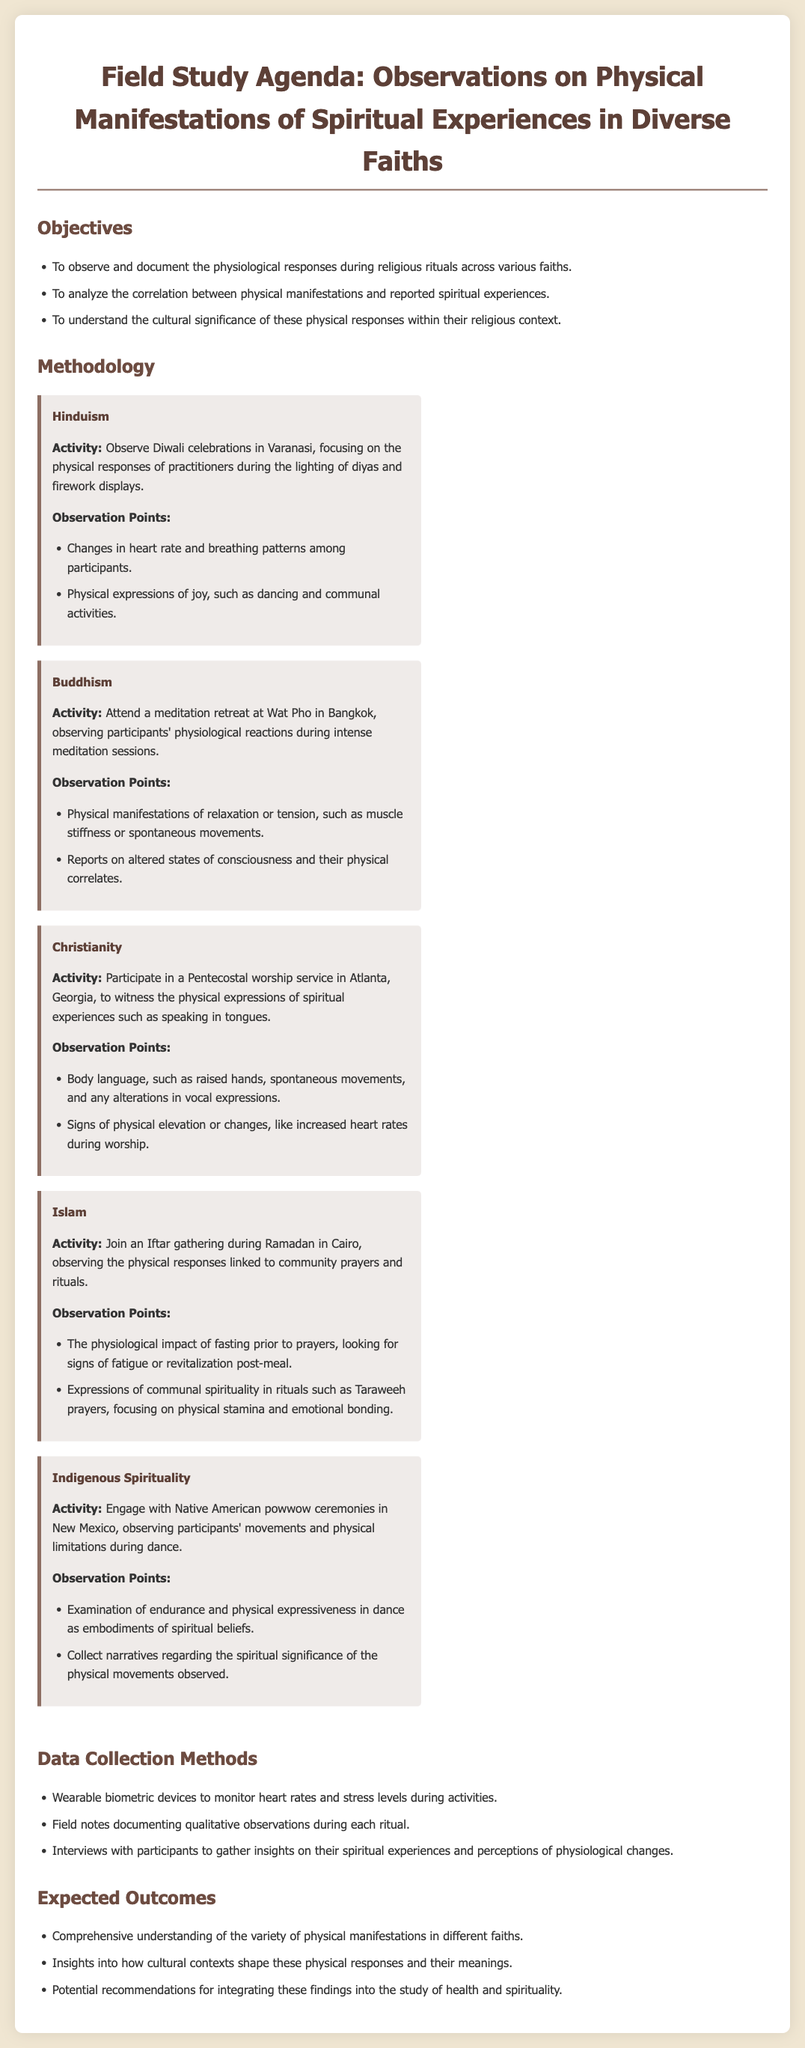What is the main focus of the field study? The main focus is to observe and document the physiological responses during religious rituals across various faiths.
Answer: physiological responses during religious rituals Which religion's activity involves observing Diwali celebrations? The activity specifically mentions observing Diwali celebrations in Varanasi.
Answer: Hinduism What physiological changes are monitored during meditation sessions in Buddhism? The observation points include physical manifestations of relaxation or tension.
Answer: relaxation or tension What type of worship service is attended for observing Christianity? The document mentions participating in a Pentecostal worship service.
Answer: Pentecostal worship service Which method is used to monitor heart rates during activities? The method mentioned is using wearable biometric devices.
Answer: wearable biometric devices What cultural context is explored in the Indigenous Spirituality section? The cultural context explored involves Native American powwow ceremonies.
Answer: Native American powwow ceremonies What are the expected outcomes of the study? One expected outcome is a comprehensive understanding of the variety of physical manifestations in different faiths.
Answer: comprehensive understanding of the variety of physical manifestations How are insights gathered from participants during the study? Insights are gathered through interviews with participants.
Answer: interviews with participants What festival is specifically observed in the Hinduism section? The festival observed is Diwali.
Answer: Diwali 